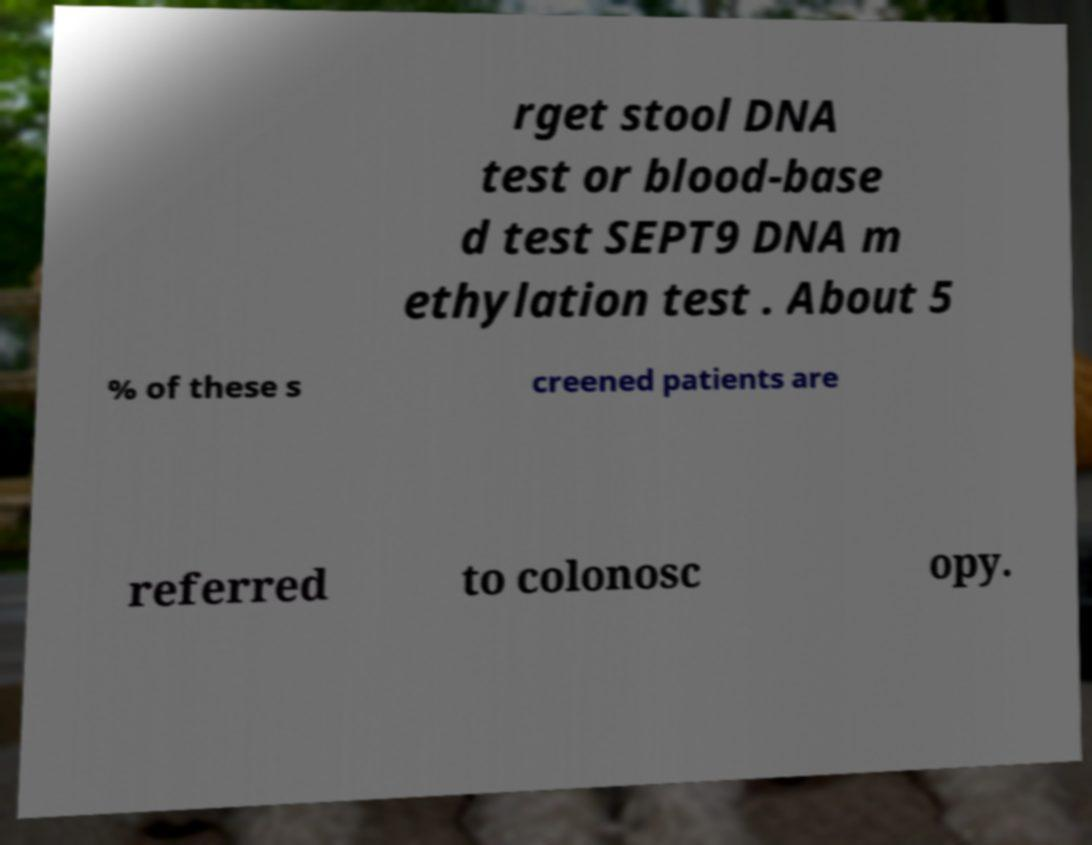There's text embedded in this image that I need extracted. Can you transcribe it verbatim? rget stool DNA test or blood-base d test SEPT9 DNA m ethylation test . About 5 % of these s creened patients are referred to colonosc opy. 